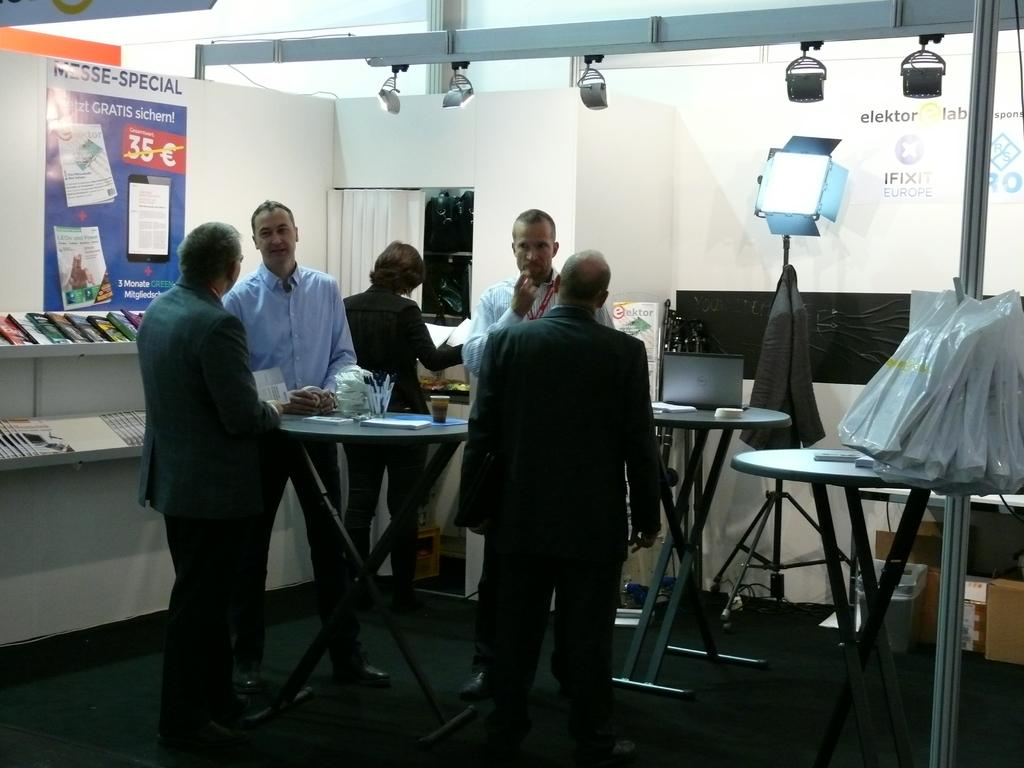How many people are in the image? There is a group of people in the image. What are the people in the image doing? The people are standing. What can be seen on the table in the image? There is a cup and papers on the table. What is on the wall in the image? There is a poster on the wall. Where are the books located in the image? The books are on a shelf. What type of illumination is present in the image? There is a light in the image. What type of airport is visible in the image? There is no airport present in the image. What fact can be learned about the bed in the image? There is no bed present in the image, so no facts about a bed can be learned. 